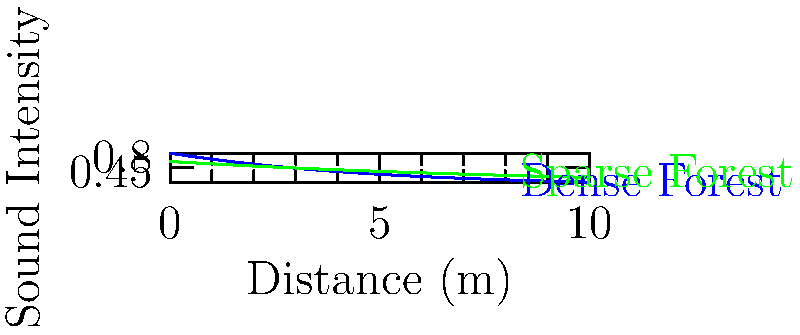As you explore different forest environments, you notice that sound travels differently through dense and sparse forests. The graph shows the relationship between sound intensity and distance for two forest types. If the initial sound intensity is the same for both forests, at what approximate distance (in meters) does the sound intensity in the dense forest become half of that in the sparse forest? To solve this problem, we need to follow these steps:

1. Identify the equations for sound intensity in each forest type:
   Dense forest: $I_d = 0.8e^{-0.2x}$
   Sparse forest: $I_s = 0.6e^{-0.1x}$

2. Set up an equation where the dense forest intensity is half of the sparse forest intensity:
   $0.8e^{-0.2x} = 0.5(0.6e^{-0.1x})$

3. Simplify the right side of the equation:
   $0.8e^{-0.2x} = 0.3e^{-0.1x}$

4. Take the natural log of both sides:
   $\ln(0.8) - 0.2x = \ln(0.3) - 0.1x$

5. Solve for x:
   $-0.223 - 0.2x = -1.204 - 0.1x$
   $-0.1x = 0.981$
   $x = -9.81$

6. Since distance cannot be negative, we take the absolute value:
   $x \approx 9.8$ meters

Therefore, the sound intensity in the dense forest becomes approximately half of that in the sparse forest at a distance of about 9.8 meters.
Answer: 9.8 meters 